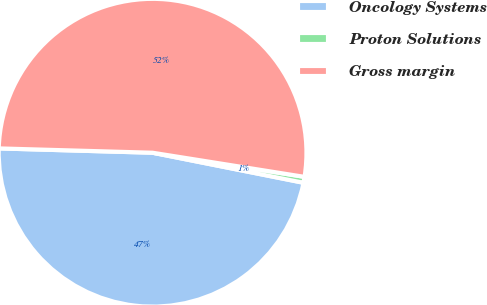<chart> <loc_0><loc_0><loc_500><loc_500><pie_chart><fcel>Oncology Systems<fcel>Proton Solutions<fcel>Gross margin<nl><fcel>47.32%<fcel>0.62%<fcel>52.06%<nl></chart> 